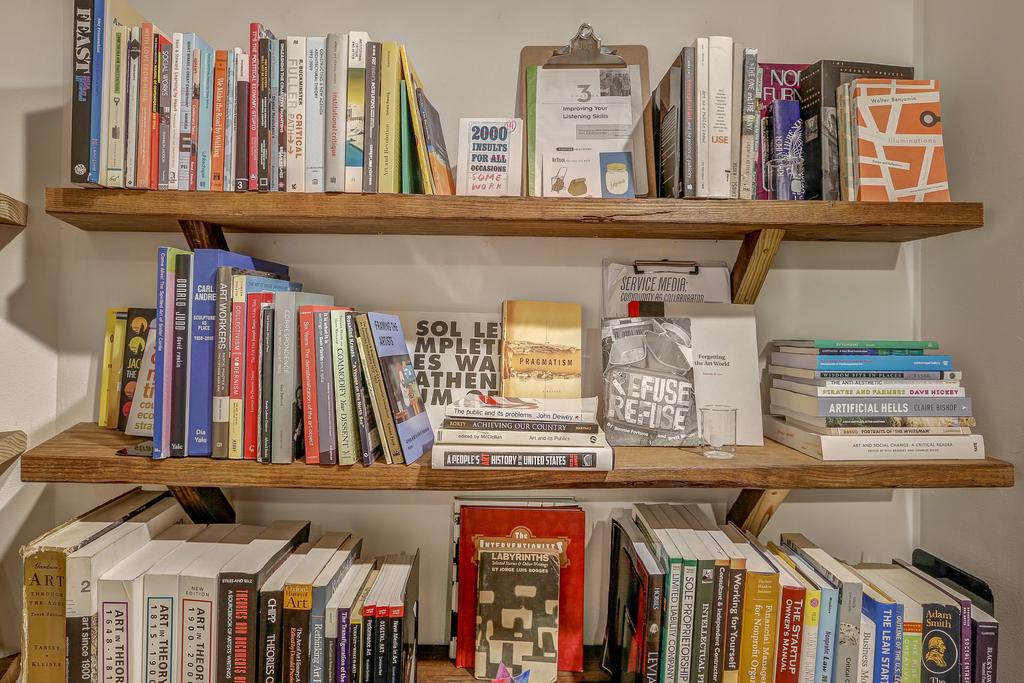What does the red book say?
Give a very brief answer. The interventionists. 